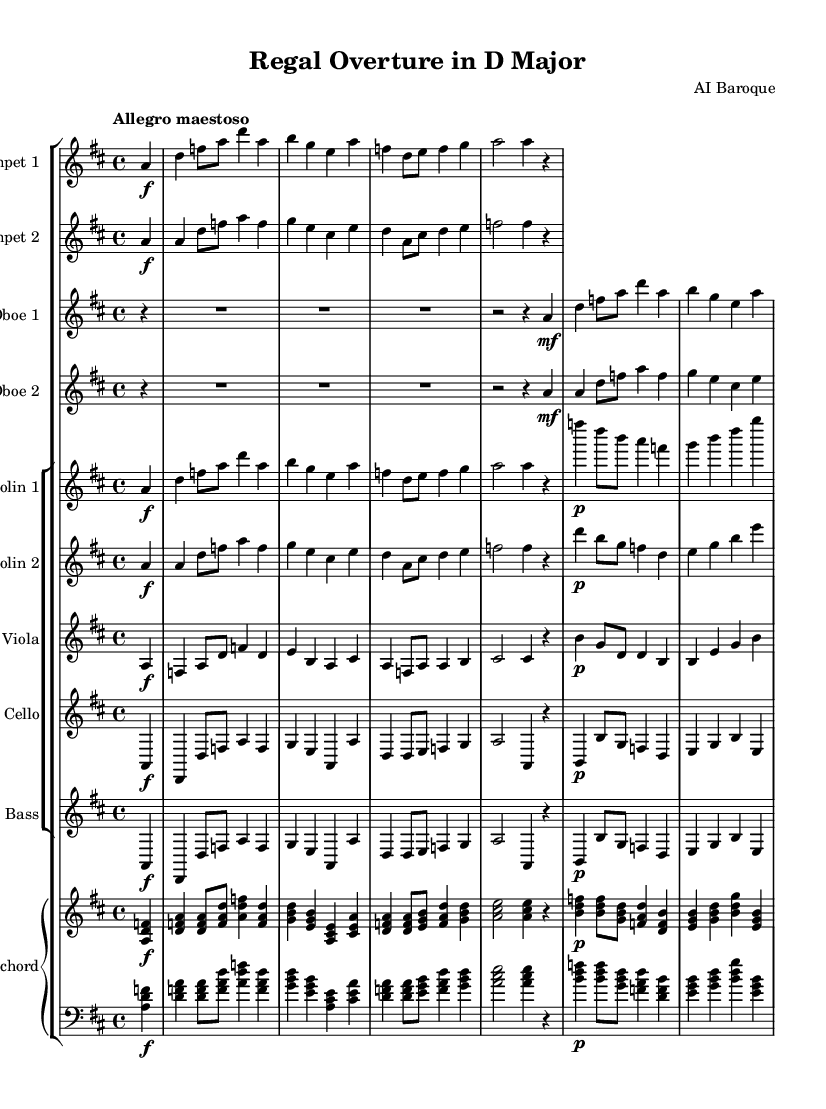What is the key signature of this music? The key signature indicates that the music is in D major, which has two sharps (F# and C#). This can be identified from the beginning of the sheet music where the key is indicated.
Answer: D major What is the time signature of this music? The time signature is 4/4, commonly used in classical music, and can be found at the beginning of the sheet music. It indicates there are four beats in each measure.
Answer: 4/4 What is the tempo marking for this piece? The tempo marking is "Allegro maestoso," found at the beginning of the sheet music, suggesting a fast, majestic speed.
Answer: Allegro maestoso How many instruments are in this orchestral piece? The orchestral piece includes seven distinct instrument parts: two trumpets, two oboes, two violins, one viola, one cello, one bass, and one harpsichord, which are all listed in the score.
Answer: Seven What is the dynamic marking for the first trumpet section? The first trumpet section begins with a forte dynamic marking, indicated by the symbol "f" that appears next to the first note, signifying a loud sound.
Answer: Forte Describe the texture of this Baroque piece based on the instruments employed. The texture is polyphonic, as evident in the multiple independent melodic lines played by the various instruments, creating a rich, layered sound typical of Baroque orchestration. This can be deduced from the diverse selection of instrumental parts written in the score.
Answer: Polyphonic What rhythmic figure is frequently repeated in the violin parts? The repeated rhythmic figure is an eighth note followed by a quarter note, observable throughout the violin sections where similar patterns appear, characterized by a driving, energetic feel common in Baroque music.
Answer: Eighth note followed by a quarter note 